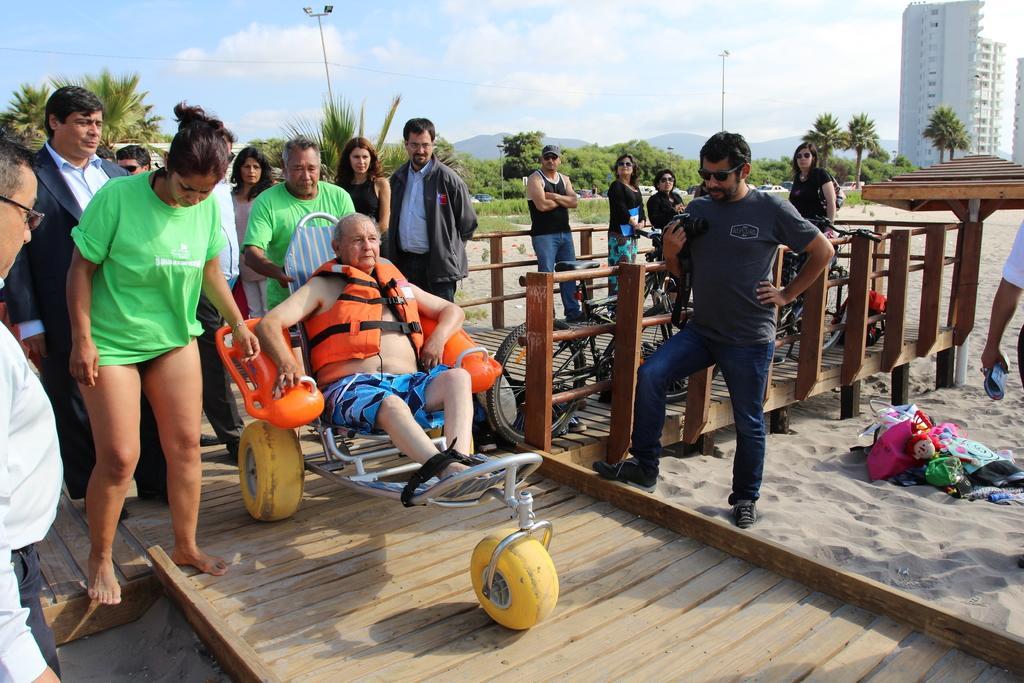Can you describe this image briefly? In this image there is the sky, there are clouds in the sky, there is a building truncated towards the right of the image, there are trees, there is a pole, there are street lights, there are group of persons standing, there is a person sitting on a vehicle, there are bicycles, there is sand, there are objects on the sand, there is a person truncated towards the right of the image, there is a person holding an object, there is an object truncated towards the right of the image, there is a person truncated towards the left of the image, there are plants. 